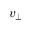<formula> <loc_0><loc_0><loc_500><loc_500>v _ { \perp }</formula> 